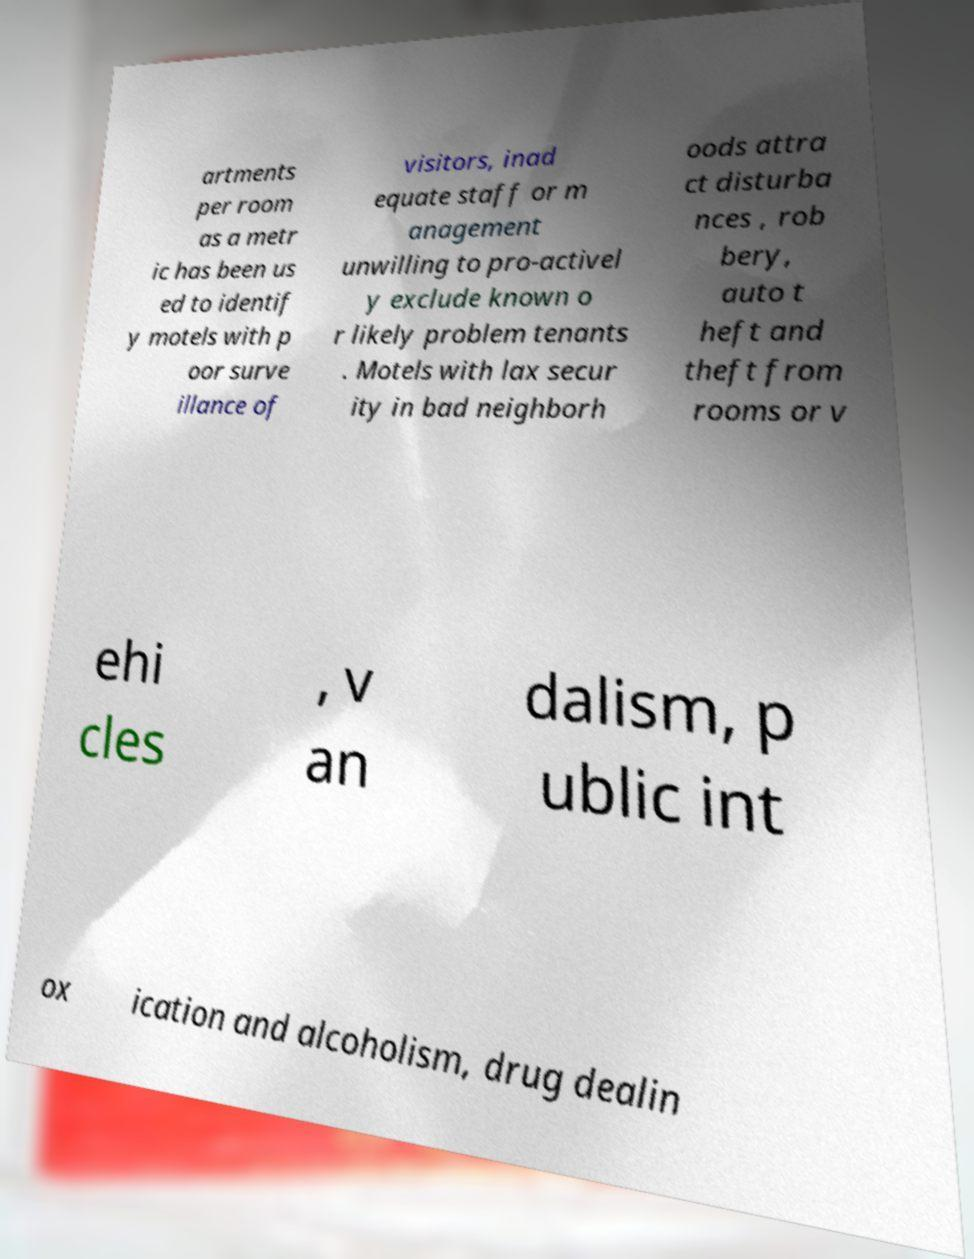Please identify and transcribe the text found in this image. artments per room as a metr ic has been us ed to identif y motels with p oor surve illance of visitors, inad equate staff or m anagement unwilling to pro-activel y exclude known o r likely problem tenants . Motels with lax secur ity in bad neighborh oods attra ct disturba nces , rob bery, auto t heft and theft from rooms or v ehi cles , v an dalism, p ublic int ox ication and alcoholism, drug dealin 